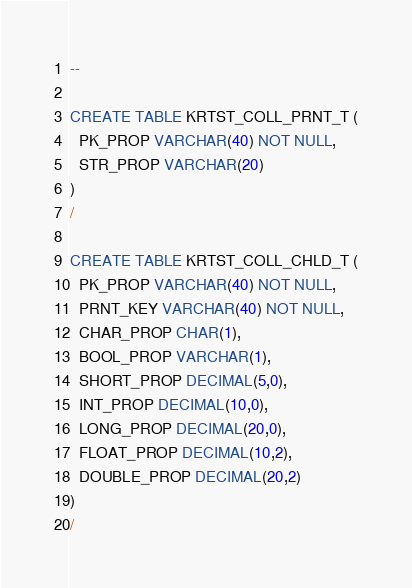Convert code to text. <code><loc_0><loc_0><loc_500><loc_500><_SQL_>--

CREATE TABLE KRTST_COLL_PRNT_T (
  PK_PROP VARCHAR(40) NOT NULL,
  STR_PROP VARCHAR(20)
)
/

CREATE TABLE KRTST_COLL_CHLD_T (
  PK_PROP VARCHAR(40) NOT NULL,
  PRNT_KEY VARCHAR(40) NOT NULL,
  CHAR_PROP CHAR(1),
  BOOL_PROP VARCHAR(1),
  SHORT_PROP DECIMAL(5,0),
  INT_PROP DECIMAL(10,0),
  LONG_PROP DECIMAL(20,0),
  FLOAT_PROP DECIMAL(10,2),
  DOUBLE_PROP DECIMAL(20,2)
)
/</code> 